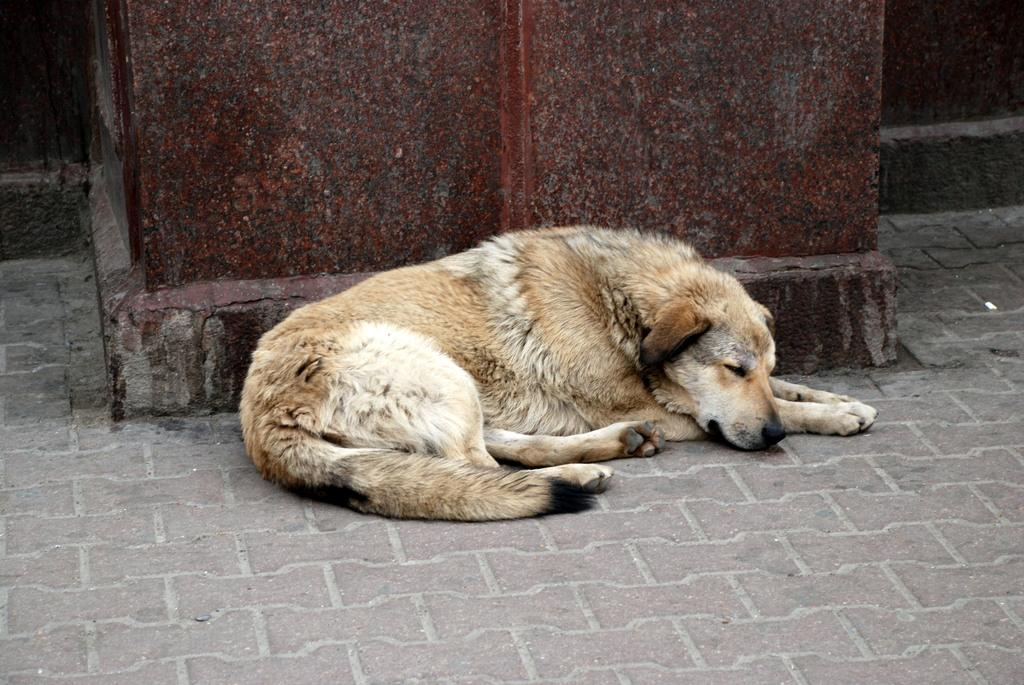What animal is present in the image? There is a dog in the image. What is the dog's position in the image? The dog is lying on the road. What other object can be seen in the image? There is a pillar in the image. What type of kettle is visible in the image? There is no kettle present in the image. What angle is the dog lying at in the image? The angle at which the dog is lying cannot be determined from the image. 